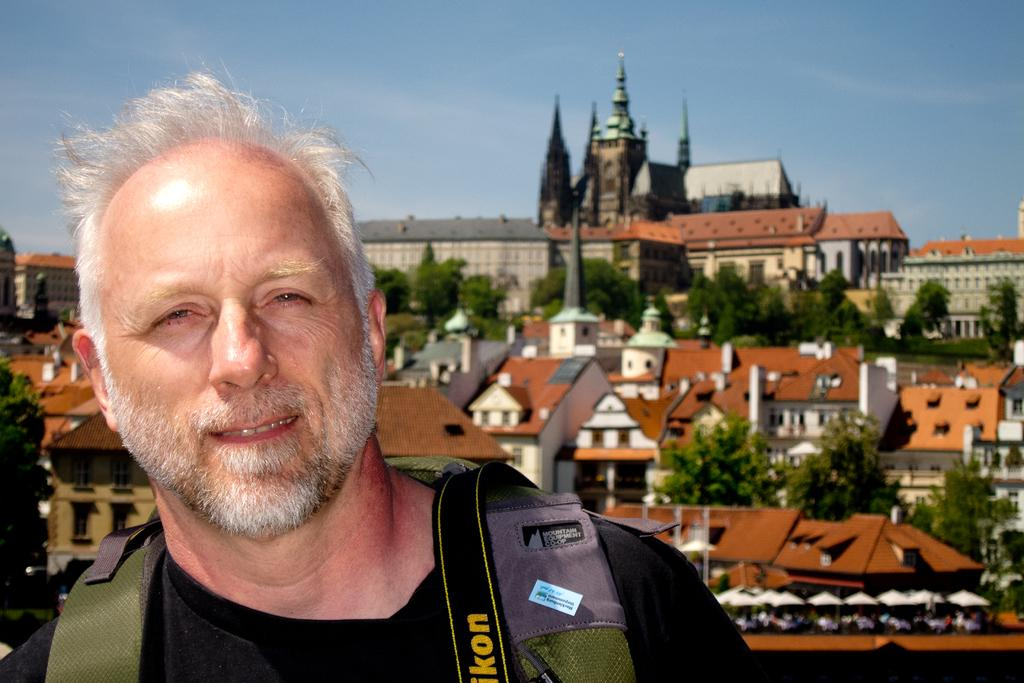What is the main subject in the foreground of the image? There is a man in the foreground of the image. What is the man wearing? The man is wearing a black t-shirt. What is the man carrying in the image? The man is carrying a bag. What can be seen in the background of the image? There are buildings, trees, and the sky visible in the background of the image. What type of hat can be smelled in the image? There is no hat present in the image, and therefore it cannot be smelled. 